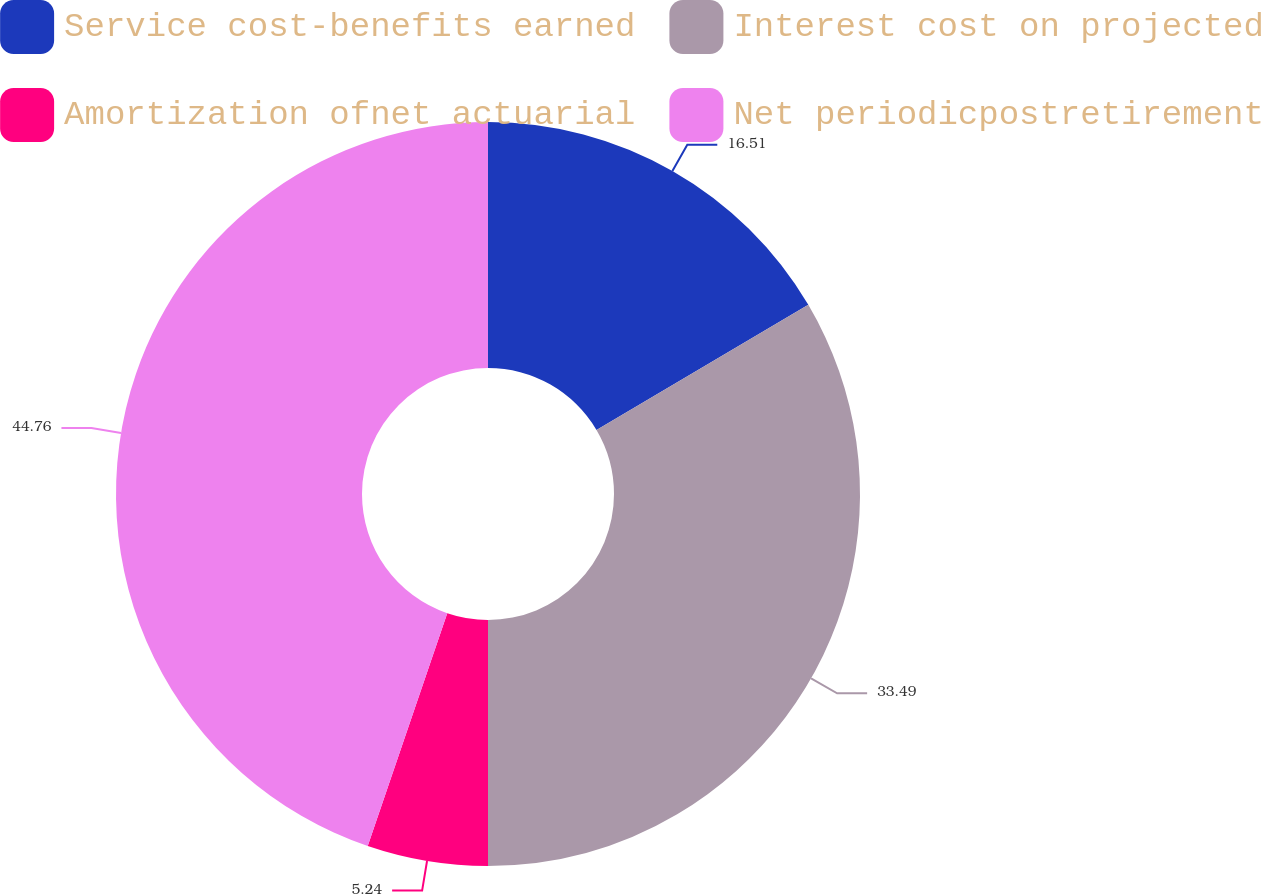<chart> <loc_0><loc_0><loc_500><loc_500><pie_chart><fcel>Service cost-benefits earned<fcel>Interest cost on projected<fcel>Amortization ofnet actuarial<fcel>Net periodicpostretirement<nl><fcel>16.51%<fcel>33.49%<fcel>5.24%<fcel>44.76%<nl></chart> 